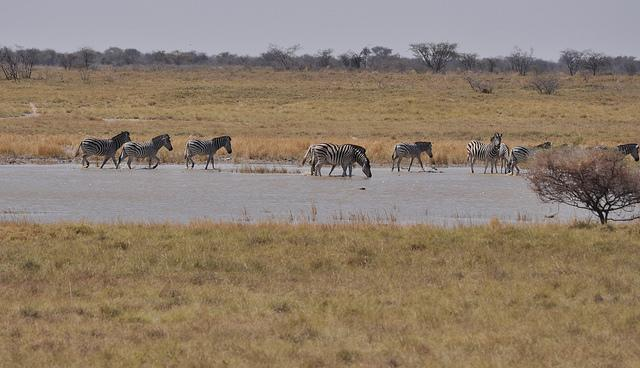What are the zebras all standing inside of?

Choices:
A) grass
B) dirt
C) stream
D) lake stream 